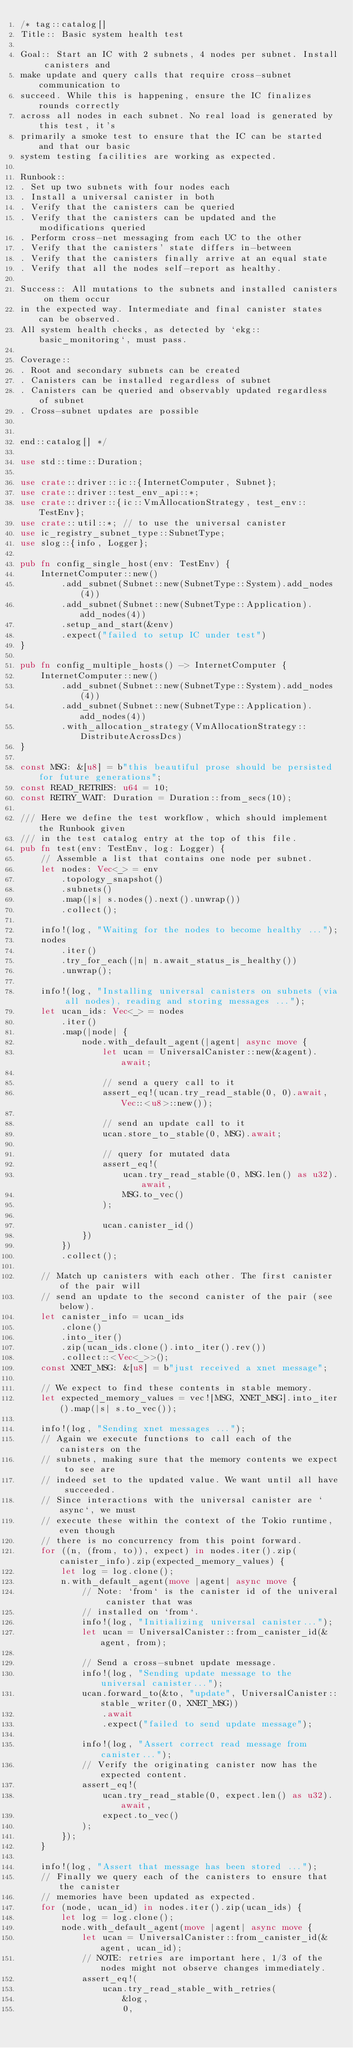<code> <loc_0><loc_0><loc_500><loc_500><_Rust_>/* tag::catalog[]
Title:: Basic system health test

Goal:: Start an IC with 2 subnets, 4 nodes per subnet. Install canisters and
make update and query calls that require cross-subnet communication to
succeed. While this is happening, ensure the IC finalizes rounds correctly
across all nodes in each subnet. No real load is generated by this test, it's
primarily a smoke test to ensure that the IC can be started and that our basic
system testing facilities are working as expected.

Runbook::
. Set up two subnets with four nodes each
. Install a universal canister in both
. Verify that the canisters can be queried
. Verify that the canisters can be updated and the modifications queried
. Perform cross-net messaging from each UC to the other
. Verify that the canisters' state differs in-between
. Verify that the canisters finally arrive at an equal state
. Verify that all the nodes self-report as healthy.

Success:: All mutations to the subnets and installed canisters on them occur
in the expected way. Intermediate and final canister states can be observed.
All system health checks, as detected by `ekg::basic_monitoring`, must pass.

Coverage::
. Root and secondary subnets can be created
. Canisters can be installed regardless of subnet
. Canisters can be queried and observably updated regardless of subnet
. Cross-subnet updates are possible


end::catalog[] */

use std::time::Duration;

use crate::driver::ic::{InternetComputer, Subnet};
use crate::driver::test_env_api::*;
use crate::driver::{ic::VmAllocationStrategy, test_env::TestEnv};
use crate::util::*; // to use the universal canister
use ic_registry_subnet_type::SubnetType;
use slog::{info, Logger};

pub fn config_single_host(env: TestEnv) {
    InternetComputer::new()
        .add_subnet(Subnet::new(SubnetType::System).add_nodes(4))
        .add_subnet(Subnet::new(SubnetType::Application).add_nodes(4))
        .setup_and_start(&env)
        .expect("failed to setup IC under test")
}

pub fn config_multiple_hosts() -> InternetComputer {
    InternetComputer::new()
        .add_subnet(Subnet::new(SubnetType::System).add_nodes(4))
        .add_subnet(Subnet::new(SubnetType::Application).add_nodes(4))
        .with_allocation_strategy(VmAllocationStrategy::DistributeAcrossDcs)
}

const MSG: &[u8] = b"this beautiful prose should be persisted for future generations";
const READ_RETRIES: u64 = 10;
const RETRY_WAIT: Duration = Duration::from_secs(10);

/// Here we define the test workflow, which should implement the Runbook given
/// in the test catalog entry at the top of this file.
pub fn test(env: TestEnv, log: Logger) {
    // Assemble a list that contains one node per subnet.
    let nodes: Vec<_> = env
        .topology_snapshot()
        .subnets()
        .map(|s| s.nodes().next().unwrap())
        .collect();

    info!(log, "Waiting for the nodes to become healthy ...");
    nodes
        .iter()
        .try_for_each(|n| n.await_status_is_healthy())
        .unwrap();

    info!(log, "Installing universal canisters on subnets (via all nodes), reading and storing messages ...");
    let ucan_ids: Vec<_> = nodes
        .iter()
        .map(|node| {
            node.with_default_agent(|agent| async move {
                let ucan = UniversalCanister::new(&agent).await;

                // send a query call to it
                assert_eq!(ucan.try_read_stable(0, 0).await, Vec::<u8>::new());

                // send an update call to it
                ucan.store_to_stable(0, MSG).await;

                // query for mutated data
                assert_eq!(
                    ucan.try_read_stable(0, MSG.len() as u32).await,
                    MSG.to_vec()
                );

                ucan.canister_id()
            })
        })
        .collect();

    // Match up canisters with each other. The first canister of the pair will
    // send an update to the second canister of the pair (see below).
    let canister_info = ucan_ids
        .clone()
        .into_iter()
        .zip(ucan_ids.clone().into_iter().rev())
        .collect::<Vec<_>>();
    const XNET_MSG: &[u8] = b"just received a xnet message";

    // We expect to find these contents in stable memory.
    let expected_memory_values = vec![MSG, XNET_MSG].into_iter().map(|s| s.to_vec());

    info!(log, "Sending xnet messages ...");
    // Again we execute functions to call each of the canisters on the
    // subnets, making sure that the memory contents we expect to see are
    // indeed set to the updated value. We want until all have succeeded.
    // Since interactions with the universal canister are `async`, we must
    // execute these within the context of the Tokio runtime, even though
    // there is no concurrency from this point forward.
    for ((n, (from, to)), expect) in nodes.iter().zip(canister_info).zip(expected_memory_values) {
        let log = log.clone();
        n.with_default_agent(move |agent| async move {
            // Note: `from` is the canister id of the univeral canister that was
            // installed on `from`.
            info!(log, "Initializing universal canister...");
            let ucan = UniversalCanister::from_canister_id(&agent, from);

            // Send a cross-subnet update message.
            info!(log, "Sending update message to the universal canister...");
            ucan.forward_to(&to, "update", UniversalCanister::stable_writer(0, XNET_MSG))
                .await
                .expect("failed to send update message");

            info!(log, "Assert correct read message from canister...");
            // Verify the originating canister now has the expected content.
            assert_eq!(
                ucan.try_read_stable(0, expect.len() as u32).await,
                expect.to_vec()
            );
        });
    }

    info!(log, "Assert that message has been stored ...");
    // Finally we query each of the canisters to ensure that the canister
    // memories have been updated as expected.
    for (node, ucan_id) in nodes.iter().zip(ucan_ids) {
        let log = log.clone();
        node.with_default_agent(move |agent| async move {
            let ucan = UniversalCanister::from_canister_id(&agent, ucan_id);
            // NOTE: retries are important here, 1/3 of the nodes might not observe changes immediately.
            assert_eq!(
                ucan.try_read_stable_with_retries(
                    &log,
                    0,</code> 